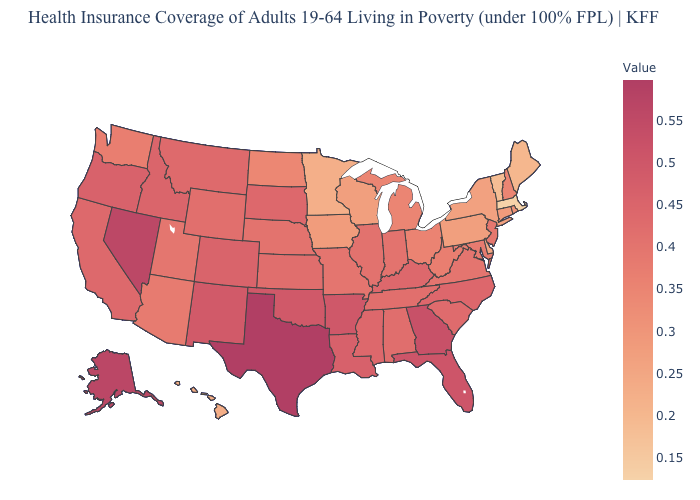Which states have the lowest value in the USA?
Quick response, please. Massachusetts. Does Texas have the highest value in the South?
Give a very brief answer. Yes. Which states have the highest value in the USA?
Write a very short answer. Texas. Among the states that border Wyoming , which have the lowest value?
Give a very brief answer. Utah. Which states have the lowest value in the West?
Concise answer only. Hawaii. Does Idaho have the highest value in the USA?
Write a very short answer. No. Which states have the highest value in the USA?
Short answer required. Texas. Does Wisconsin have a higher value than Massachusetts?
Write a very short answer. Yes. Does the map have missing data?
Be succinct. No. 